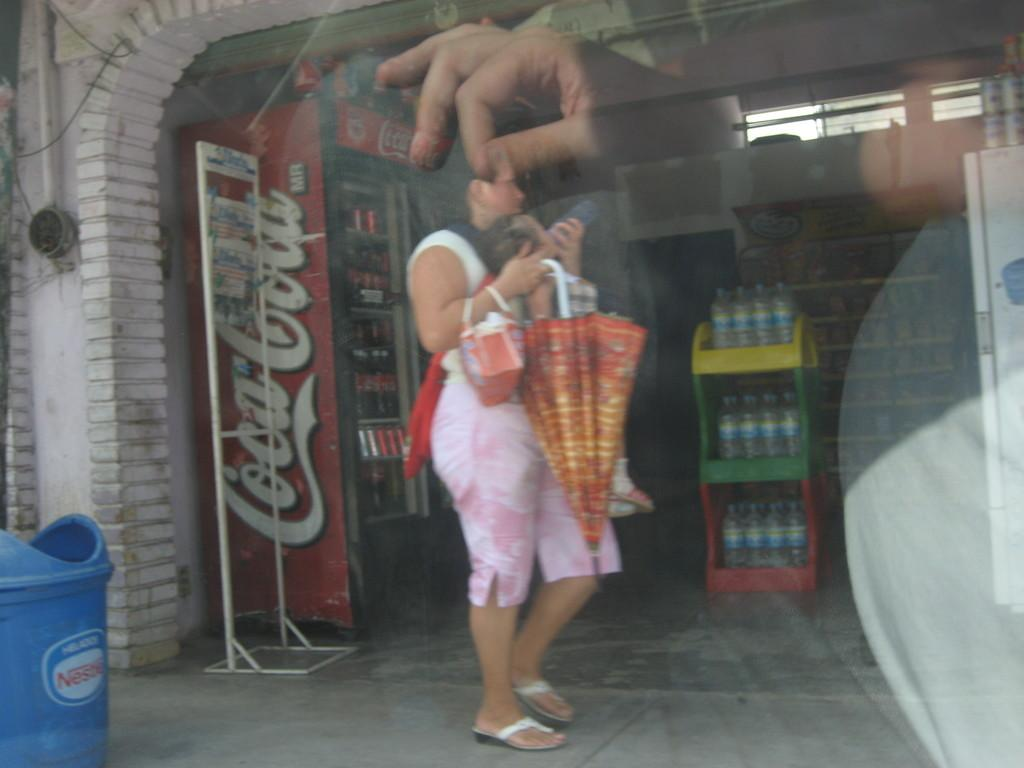<image>
Relay a brief, clear account of the picture shown. A woman near a Coca Cola machine is being pinched by the reflection of a man's hand in the glass. 